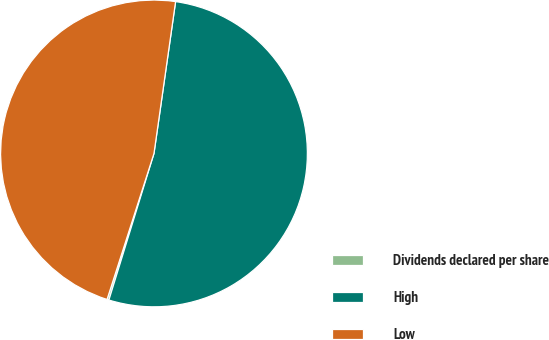<chart> <loc_0><loc_0><loc_500><loc_500><pie_chart><fcel>Dividends declared per share<fcel>High<fcel>Low<nl><fcel>0.2%<fcel>52.5%<fcel>47.3%<nl></chart> 